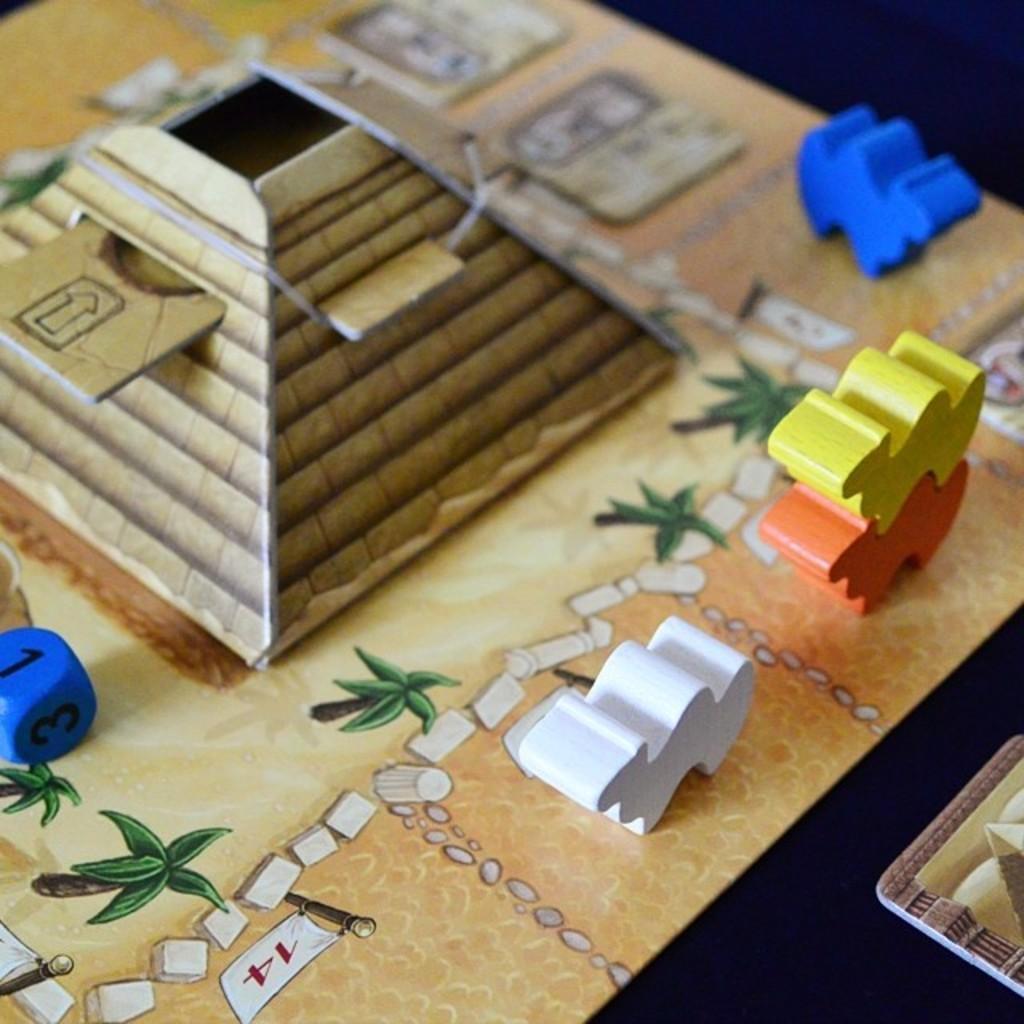Describe this image in one or two sentences. In this image we can see a few boards. We can see the painting of trees, a flag and few other objects in the image. There are few objects placed on the board. There is a die at the left side of the image. There is a board at the right side of the image. 